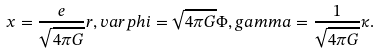<formula> <loc_0><loc_0><loc_500><loc_500>x = \frac { e } { \sqrt { 4 \pi G } } r , v a r p h i = \sqrt { 4 \pi G } \Phi , g a m m a = \frac { 1 } { \sqrt { 4 \pi G } } \kappa .</formula> 